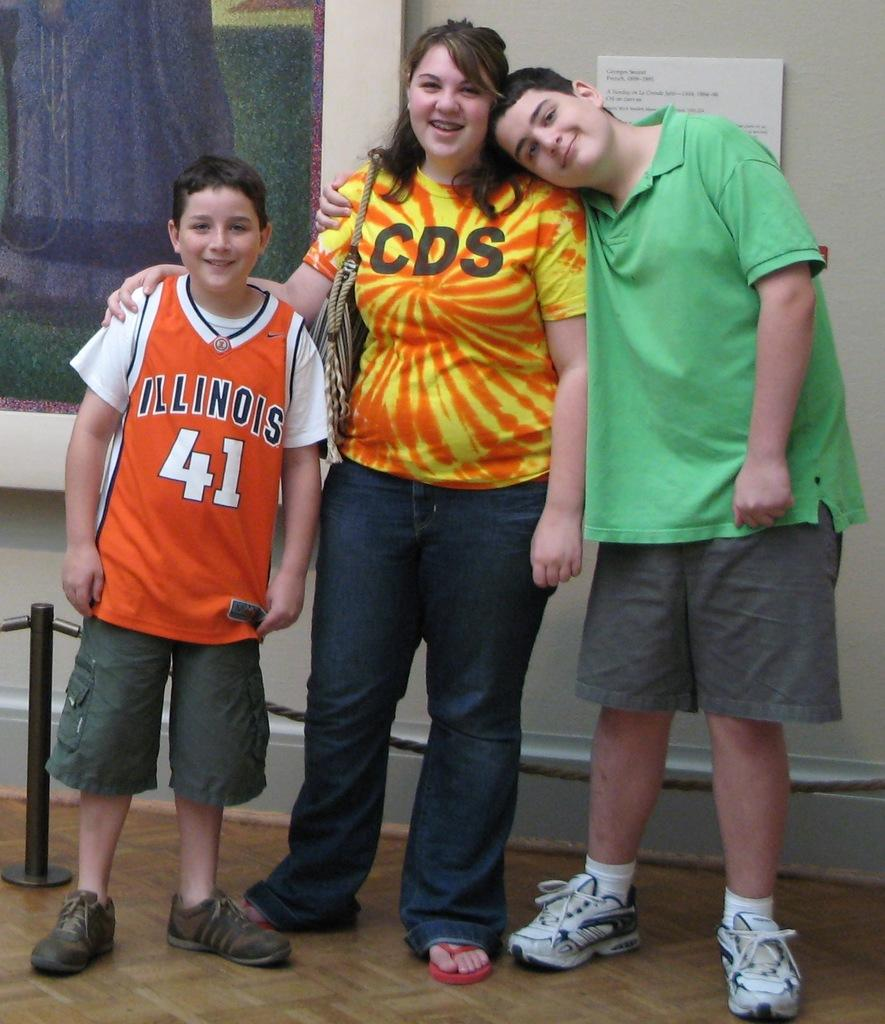Provide a one-sentence caption for the provided image. two young boys and one woman wearing a t-shirt with "CDS" logo posing for a photo in an art museum. 